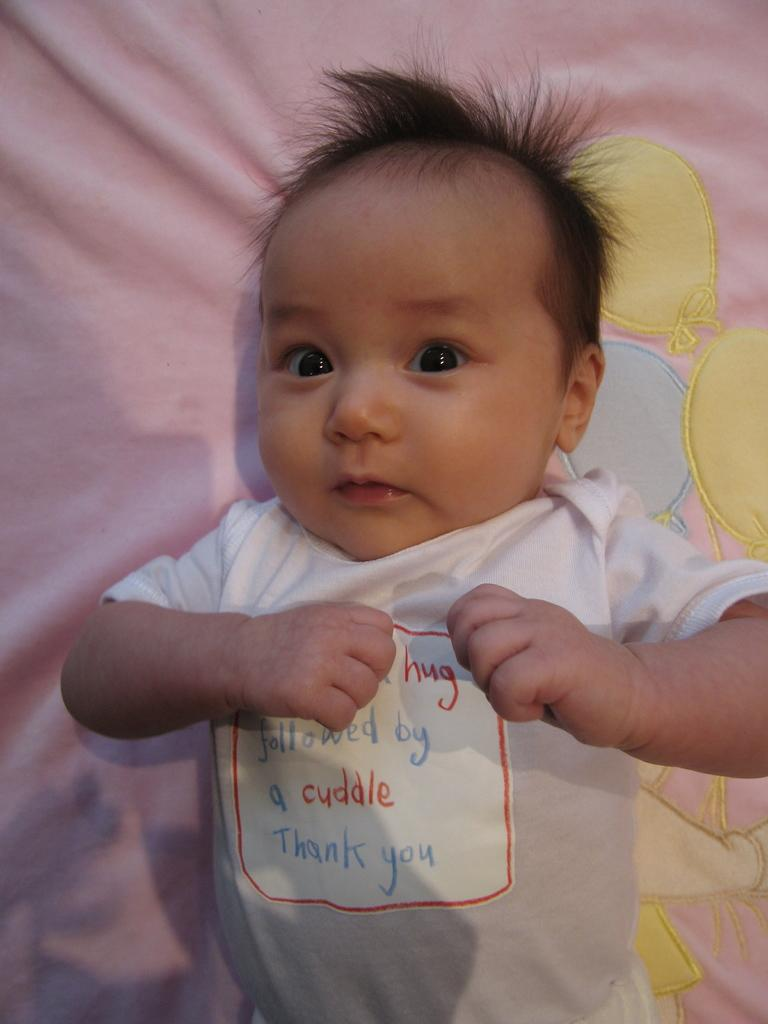What is the main subject of the image? There is a baby in the image. What is the baby wearing? The baby is wearing a white T-shirt. What color is the blanket the baby is lying on? The baby is lying on a pink color blanket. Is there any text visible on the baby's clothing? Yes, there is text written on the T-shirt. What type of oil is being used to push the baby's account in the image? There is no oil, pushing, or account present in the image. 